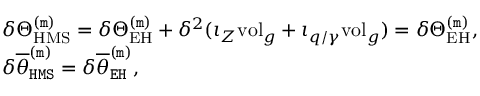<formula> <loc_0><loc_0><loc_500><loc_500>\begin{array} { r l } & { \delta \Theta _ { H M S } ^ { ( m ) } = \delta \Theta _ { E H } ^ { ( m ) } + \delta ^ { 2 } ( \iota _ { Z } v o l _ { g } + \iota _ { q / \gamma } v o l _ { g } ) = \delta \Theta _ { E H } ^ { ( m ) } , } \\ & { \delta \overline { \theta } _ { H M S } ^ { ( m ) } = \delta \overline { \theta } _ { E H } ^ { ( m ) } , } \end{array}</formula> 